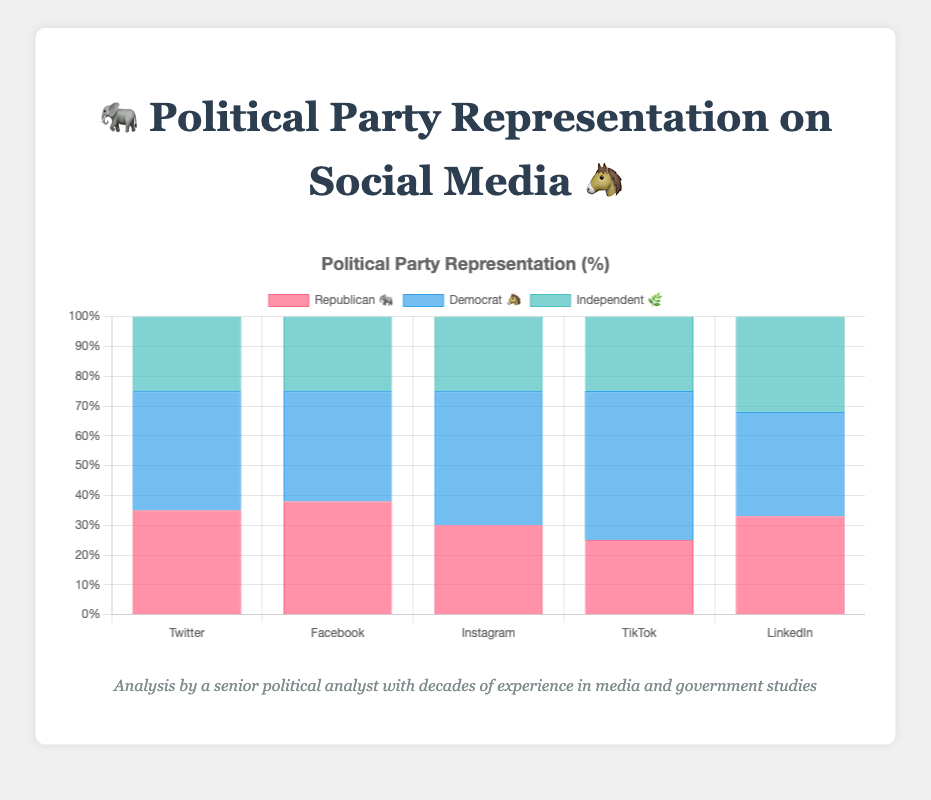What is the title of the chart? The title is displayed at the top of the chart. It reads "Political Party Representation on Social Media" with emojis representing the different political parties.
Answer: Political Party Representation on Social Media 🐘🐴 How many platforms are represented in the chart? The x-axis labels of the chart show each social media platform where political party representation is measured. There are five platforms listed: Twitter, Facebook, Instagram, TikTok, and LinkedIn.
Answer: 5 Which party has the highest representation on Instagram? By observing the bar heights corresponding to Instagram, the tallest bar is for the Democrat party, which is labeled "Democrat 🐴" with a value of 45.
Answer: Democrat 🐴 What is the combined representation of Independents on all platforms? Summing up the values for the Independent 🌿 party across all platforms: 25 (Twitter) + 25 (Facebook) + 25 (Instagram) + 25 (TikTok) + 32 (LinkedIn) gives a total of 132.
Answer: 132 Which social media platform shows the most balanced representation across all political parties? LinkedIn appears most balanced with values for parties: Republican 🐘 (33), Democrat 🐴 (35), and Independent 🌿 (32), which are close to each other.
Answer: LinkedIn On which platform do the Democrats have a 50% representation? By examining the chart, Democrats have a 50% representation on TikTok, as indicated by the height of the bar.
Answer: TikTok How much more representation do Republicans have on Facebook compared to TikTok? Locate the bars for Republicans on both platforms: Facebook (38) and TikTok (25), and compute the difference: 38 - 25 = 13.
Answer: 13 What percentage of representation do Republicans have on LinkedIn? From the chart, the bar for Republicans on LinkedIn indicates a representation value of 33%.
Answer: 33% Which social media platform has the largest gap in representation between Democrats and Republicans? By calculating the difference for each platform:
- Twitter: 40 - 35 = 5
- Facebook: 38 - 37 = 1
- Instagram: 45 - 30 = 15
- TikTok: 50 - 25 = 25
- LinkedIn: 35 - 33 = 2
The largest gap is on TikTok with 25%.
Answer: TikTok 